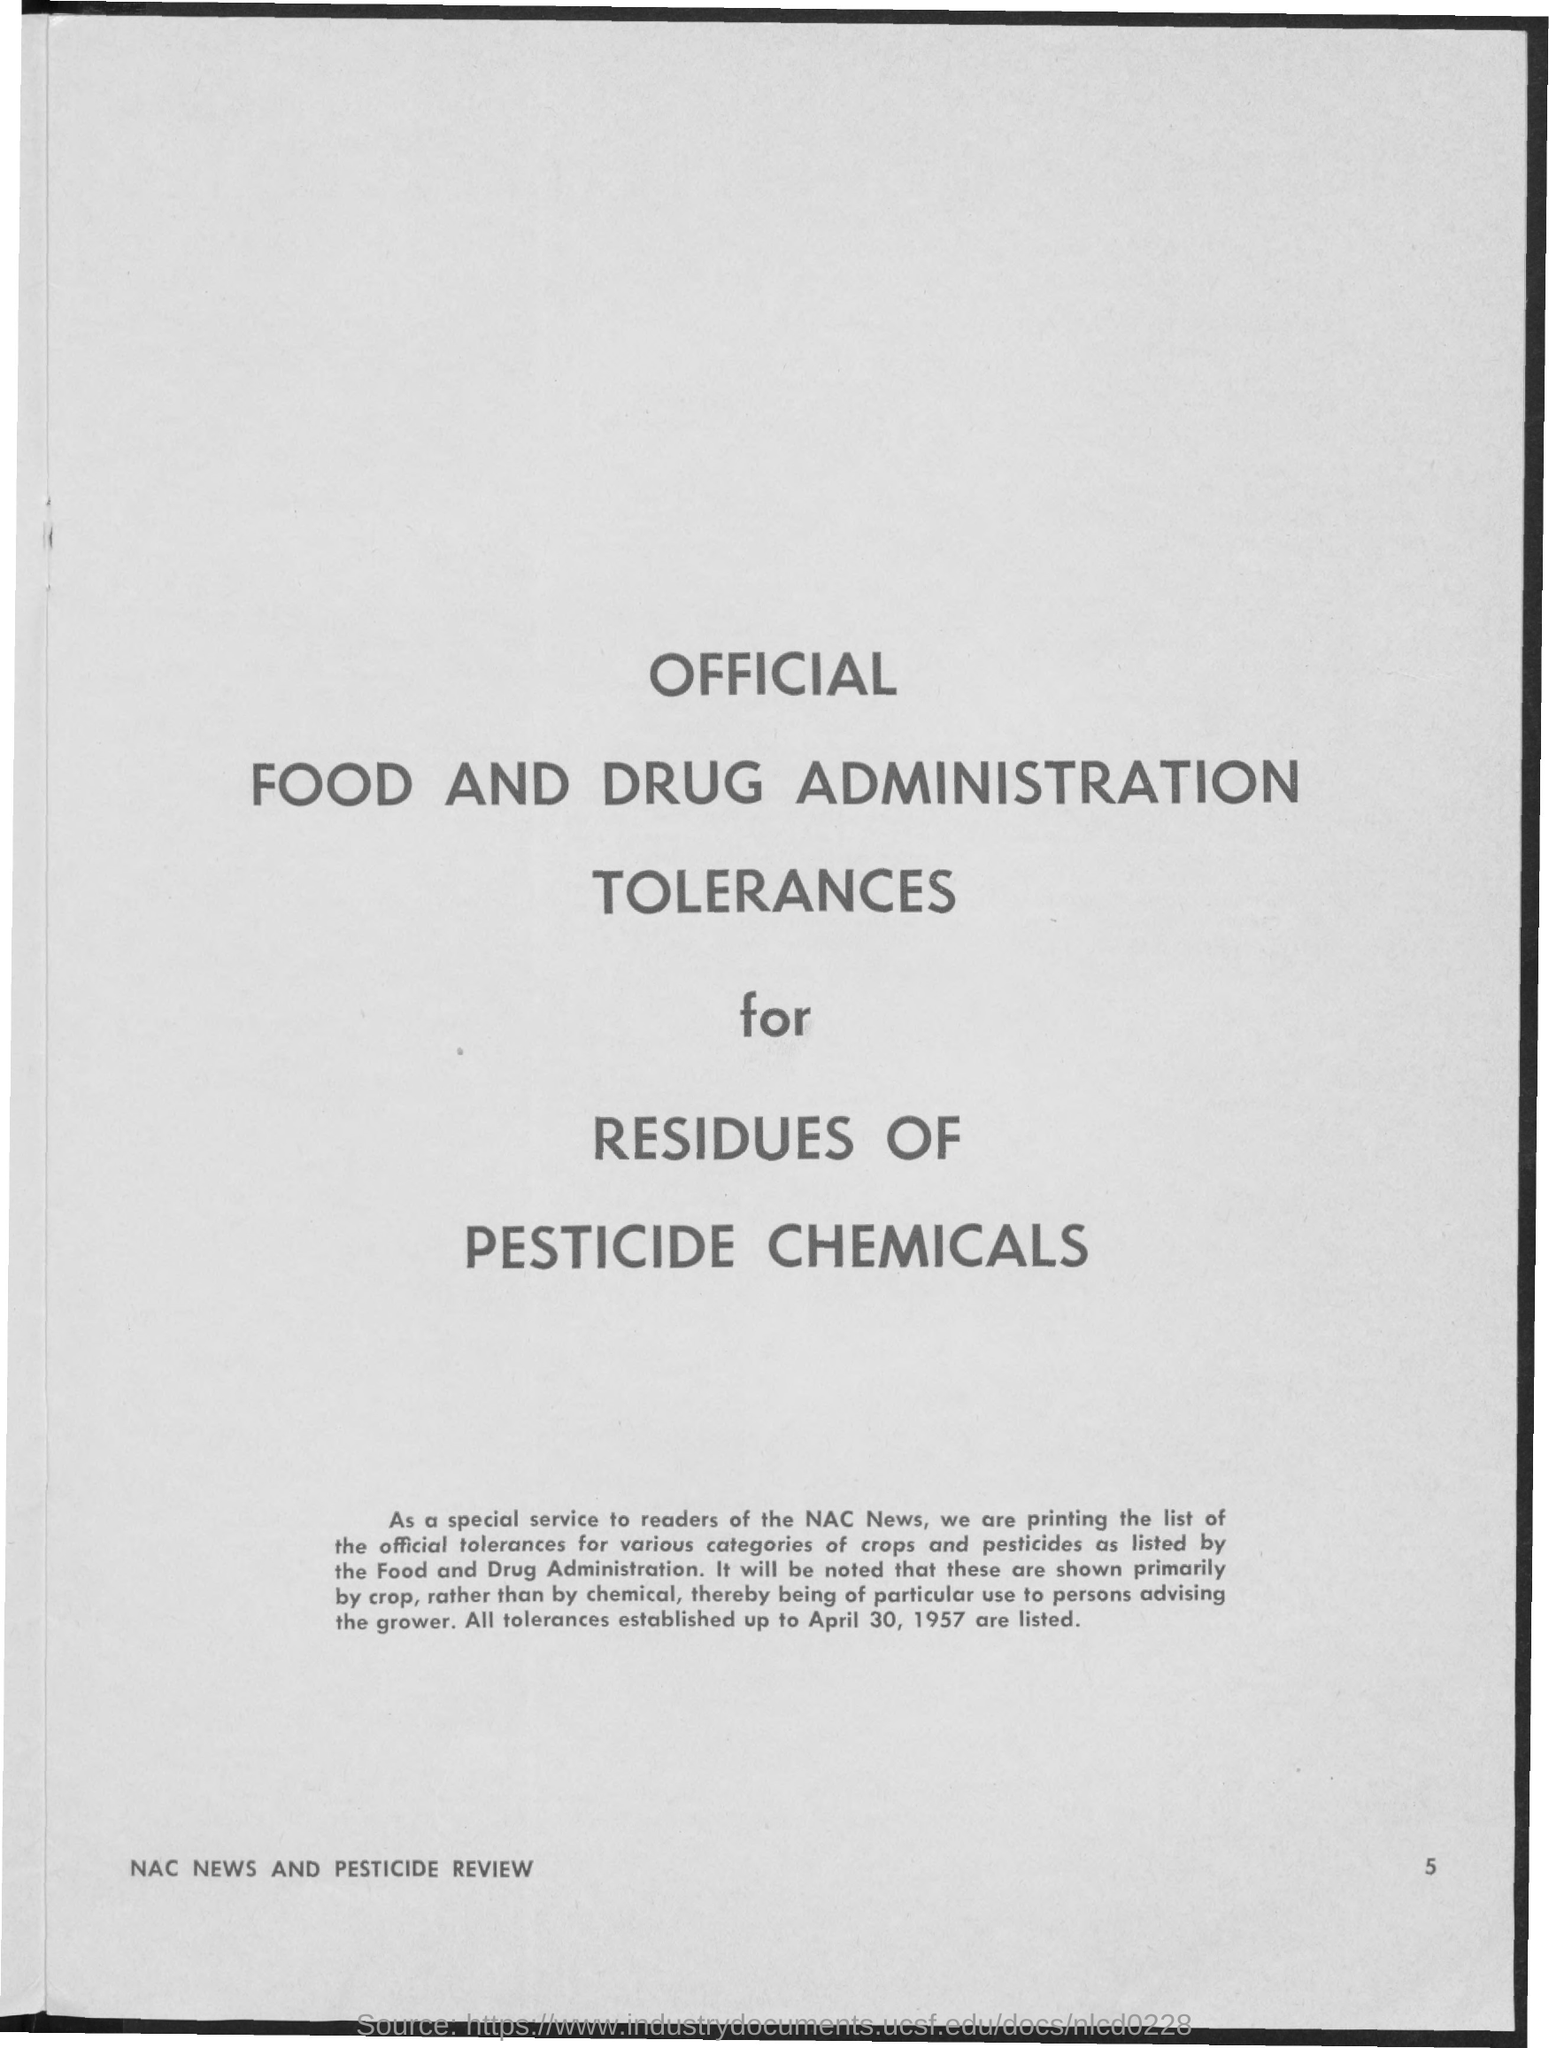What is the Page Number?
Your response must be concise. 5. What is the title of the document?
Provide a succinct answer. Official Food and Drug Administration Tolerances for Residues of Pesticide Chemicals. 